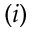<formula> <loc_0><loc_0><loc_500><loc_500>( i )</formula> 